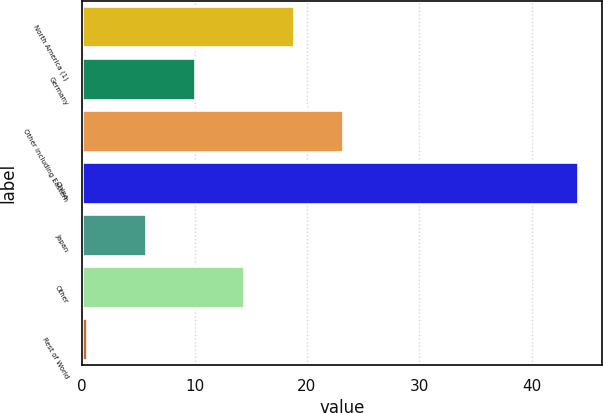<chart> <loc_0><loc_0><loc_500><loc_500><bar_chart><fcel>North America (1)<fcel>Germany<fcel>Other including Eastern<fcel>China<fcel>Japan<fcel>Other<fcel>Rest of World<nl><fcel>18.81<fcel>10.07<fcel>23.18<fcel>44.1<fcel>5.7<fcel>14.44<fcel>0.4<nl></chart> 